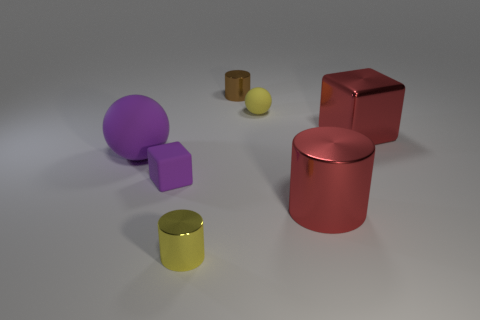Subtract all tiny cylinders. How many cylinders are left? 1 Add 1 big balls. How many objects exist? 8 Subtract all blocks. How many objects are left? 5 Add 3 big yellow cylinders. How many big yellow cylinders exist? 3 Subtract 0 purple cylinders. How many objects are left? 7 Subtract all big shiny cylinders. Subtract all small purple objects. How many objects are left? 5 Add 4 big cylinders. How many big cylinders are left? 5 